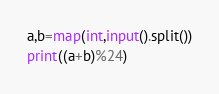Convert code to text. <code><loc_0><loc_0><loc_500><loc_500><_Python_>a,b=map(int,input().split())
print((a+b)%24)</code> 